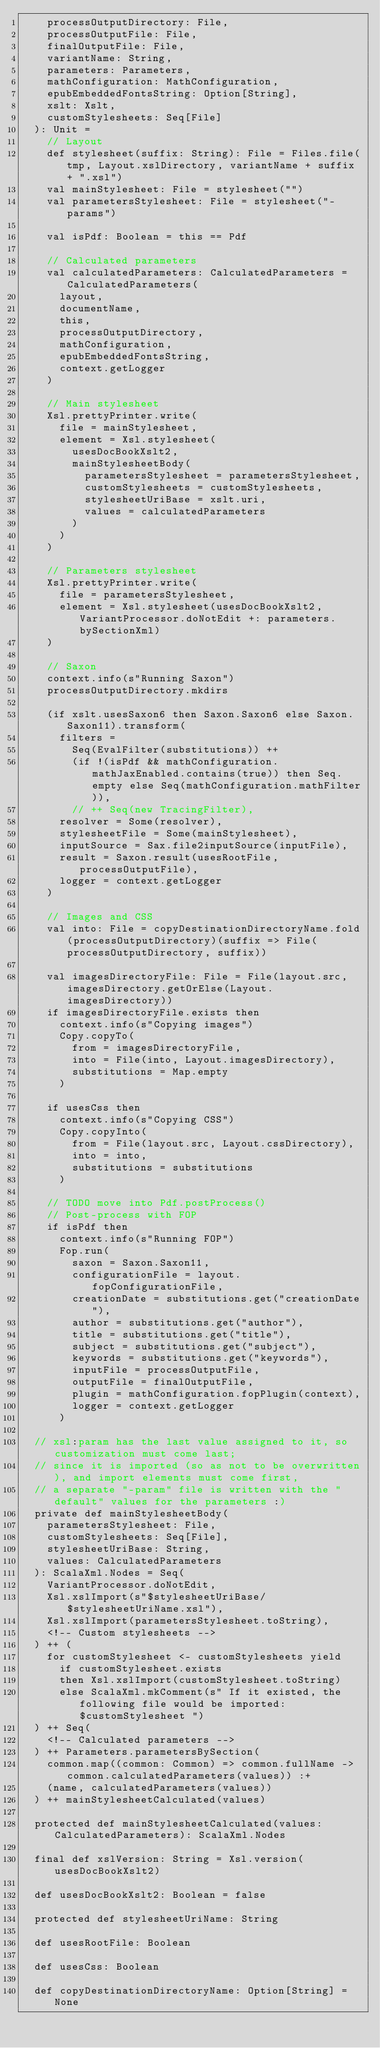<code> <loc_0><loc_0><loc_500><loc_500><_Scala_>    processOutputDirectory: File,
    processOutputFile: File,
    finalOutputFile: File,
    variantName: String,
    parameters: Parameters,
    mathConfiguration: MathConfiguration,
    epubEmbeddedFontsString: Option[String],
    xslt: Xslt,
    customStylesheets: Seq[File]
  ): Unit =
    // Layout
    def stylesheet(suffix: String): File = Files.file(tmp, Layout.xslDirectory, variantName + suffix + ".xsl")
    val mainStylesheet: File = stylesheet("")
    val parametersStylesheet: File = stylesheet("-params")

    val isPdf: Boolean = this == Pdf

    // Calculated parameters
    val calculatedParameters: CalculatedParameters = CalculatedParameters(
      layout,
      documentName,
      this,
      processOutputDirectory,
      mathConfiguration,
      epubEmbeddedFontsString,
      context.getLogger
    )

    // Main stylesheet
    Xsl.prettyPrinter.write(
      file = mainStylesheet,
      element = Xsl.stylesheet(
        usesDocBookXslt2,
        mainStylesheetBody(
          parametersStylesheet = parametersStylesheet,
          customStylesheets = customStylesheets,
          stylesheetUriBase = xslt.uri,
          values = calculatedParameters
        )
      )
    )

    // Parameters stylesheet
    Xsl.prettyPrinter.write(
      file = parametersStylesheet,
      element = Xsl.stylesheet(usesDocBookXslt2, VariantProcessor.doNotEdit +: parameters.bySectionXml)
    )

    // Saxon
    context.info(s"Running Saxon")
    processOutputDirectory.mkdirs

    (if xslt.usesSaxon6 then Saxon.Saxon6 else Saxon.Saxon11).transform(
      filters =
        Seq(EvalFilter(substitutions)) ++
        (if !(isPdf && mathConfiguration.mathJaxEnabled.contains(true)) then Seq.empty else Seq(mathConfiguration.mathFilter)),
        // ++ Seq(new TracingFilter),
      resolver = Some(resolver),
      stylesheetFile = Some(mainStylesheet),
      inputSource = Sax.file2inputSource(inputFile),
      result = Saxon.result(usesRootFile, processOutputFile),
      logger = context.getLogger
    )

    // Images and CSS
    val into: File = copyDestinationDirectoryName.fold(processOutputDirectory)(suffix => File(processOutputDirectory, suffix))

    val imagesDirectoryFile: File = File(layout.src, imagesDirectory.getOrElse(Layout.imagesDirectory))
    if imagesDirectoryFile.exists then
      context.info(s"Copying images")
      Copy.copyTo(
        from = imagesDirectoryFile,
        into = File(into, Layout.imagesDirectory),
        substitutions = Map.empty
      )

    if usesCss then
      context.info(s"Copying CSS")
      Copy.copyInto(
        from = File(layout.src, Layout.cssDirectory),
        into = into,
        substitutions = substitutions
      )

    // TODO move into Pdf.postProcess()
    // Post-process with FOP
    if isPdf then
      context.info(s"Running FOP")
      Fop.run(
        saxon = Saxon.Saxon11,
        configurationFile = layout.fopConfigurationFile,
        creationDate = substitutions.get("creationDate"),
        author = substitutions.get("author"),
        title = substitutions.get("title"),
        subject = substitutions.get("subject"),
        keywords = substitutions.get("keywords"),
        inputFile = processOutputFile,
        outputFile = finalOutputFile,
        plugin = mathConfiguration.fopPlugin(context),
        logger = context.getLogger
      )

  // xsl:param has the last value assigned to it, so customization must come last;
  // since it is imported (so as not to be overwritten), and import elements must come first,
  // a separate "-param" file is written with the "default" values for the parameters :)
  private def mainStylesheetBody(
    parametersStylesheet: File,
    customStylesheets: Seq[File],
    stylesheetUriBase: String,
    values: CalculatedParameters
  ): ScalaXml.Nodes = Seq(
    VariantProcessor.doNotEdit,
    Xsl.xslImport(s"$stylesheetUriBase/$stylesheetUriName.xsl"),
    Xsl.xslImport(parametersStylesheet.toString),
    <!-- Custom stylesheets -->
  ) ++ (
    for customStylesheet <- customStylesheets yield
      if customStylesheet.exists
      then Xsl.xslImport(customStylesheet.toString)
      else ScalaXml.mkComment(s" If it existed, the following file would be imported: $customStylesheet ")
  ) ++ Seq(
    <!-- Calculated parameters -->
  ) ++ Parameters.parametersBySection(
    common.map((common: Common) => common.fullName -> common.calculatedParameters(values)) :+
    (name, calculatedParameters(values))
  ) ++ mainStylesheetCalculated(values)

  protected def mainStylesheetCalculated(values: CalculatedParameters): ScalaXml.Nodes

  final def xslVersion: String = Xsl.version(usesDocBookXslt2)

  def usesDocBookXslt2: Boolean = false

  protected def stylesheetUriName: String

  def usesRootFile: Boolean

  def usesCss: Boolean

  def copyDestinationDirectoryName: Option[String] = None
</code> 